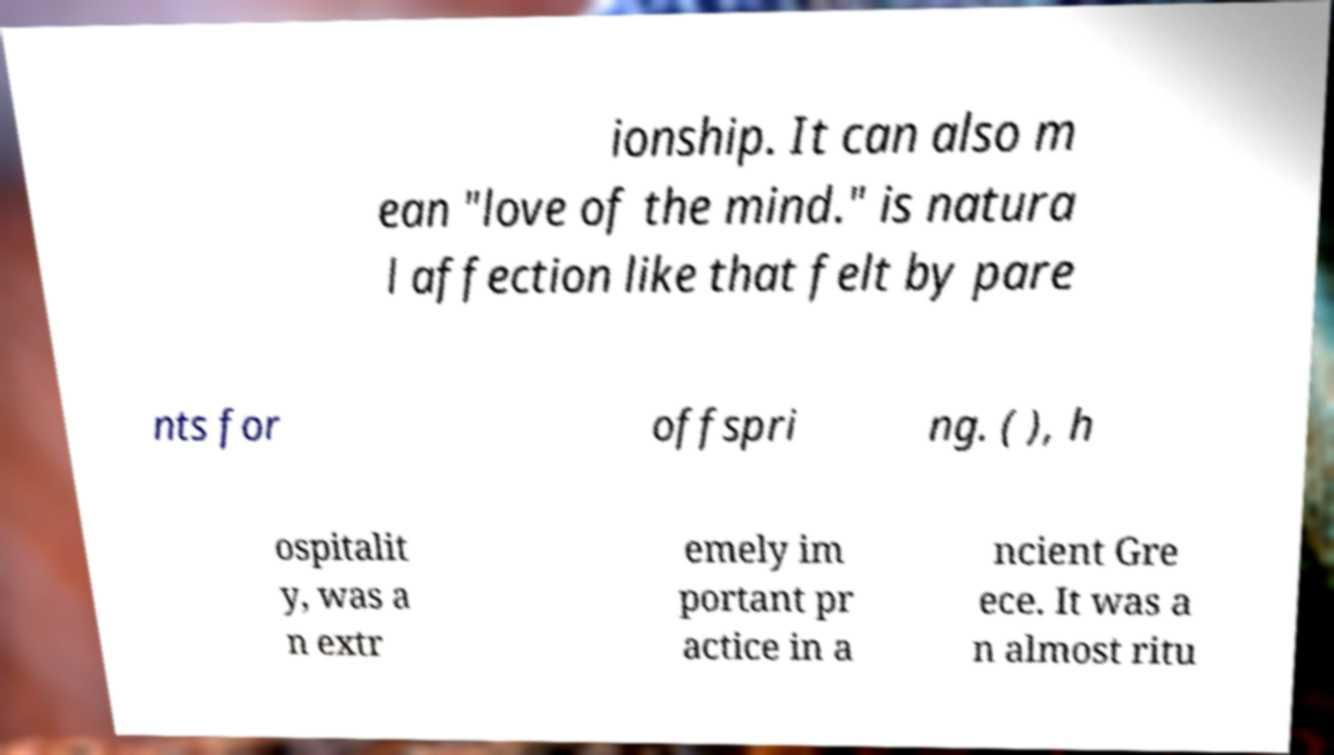Could you assist in decoding the text presented in this image and type it out clearly? ionship. It can also m ean "love of the mind." is natura l affection like that felt by pare nts for offspri ng. ( ), h ospitalit y, was a n extr emely im portant pr actice in a ncient Gre ece. It was a n almost ritu 